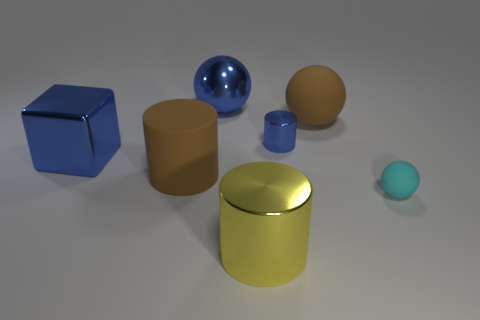What is the color of the big metal ball?
Your answer should be compact. Blue. Are there any large blocks that have the same color as the large rubber ball?
Your answer should be very brief. No. Does the metallic cylinder behind the small matte sphere have the same color as the large matte cylinder?
Offer a terse response. No. What number of things are blue things that are behind the large shiny cube or big blue rubber blocks?
Give a very brief answer. 2. Are there any blocks in front of the large metal sphere?
Your answer should be compact. Yes. There is a tiny thing that is the same color as the metal ball; what material is it?
Provide a succinct answer. Metal. Is the ball that is in front of the big blue block made of the same material as the tiny blue object?
Your response must be concise. No. There is a big rubber thing that is in front of the blue shiny thing left of the rubber cylinder; are there any big blue metal spheres in front of it?
Make the answer very short. No. How many cylinders are small cyan metal things or large blue things?
Offer a terse response. 0. What is the material of the cylinder behind the big blue shiny cube?
Give a very brief answer. Metal. 